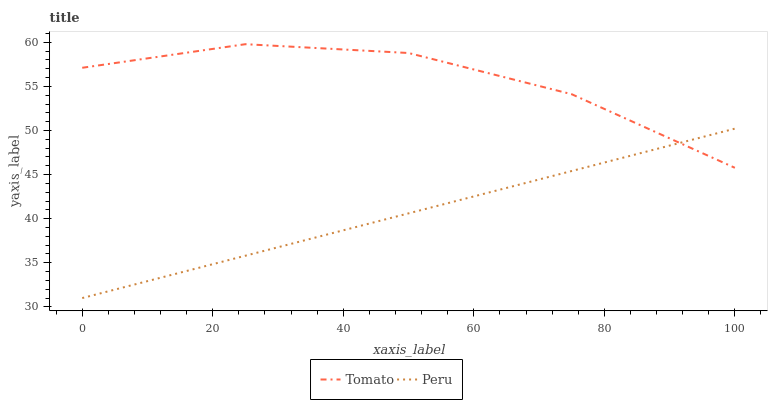Does Peru have the minimum area under the curve?
Answer yes or no. Yes. Does Tomato have the maximum area under the curve?
Answer yes or no. Yes. Does Peru have the maximum area under the curve?
Answer yes or no. No. Is Peru the smoothest?
Answer yes or no. Yes. Is Tomato the roughest?
Answer yes or no. Yes. Is Peru the roughest?
Answer yes or no. No. Does Peru have the lowest value?
Answer yes or no. Yes. Does Tomato have the highest value?
Answer yes or no. Yes. Does Peru have the highest value?
Answer yes or no. No. Does Peru intersect Tomato?
Answer yes or no. Yes. Is Peru less than Tomato?
Answer yes or no. No. Is Peru greater than Tomato?
Answer yes or no. No. 